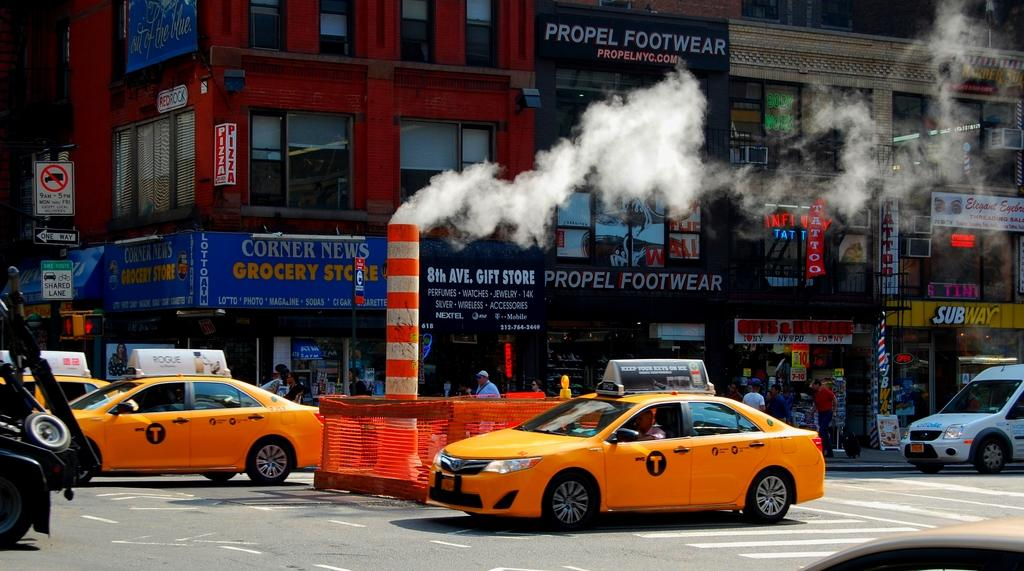<image>
Write a terse but informative summary of the picture. Yellow cabs are in an intersection in front of a Propel Footwear store. 